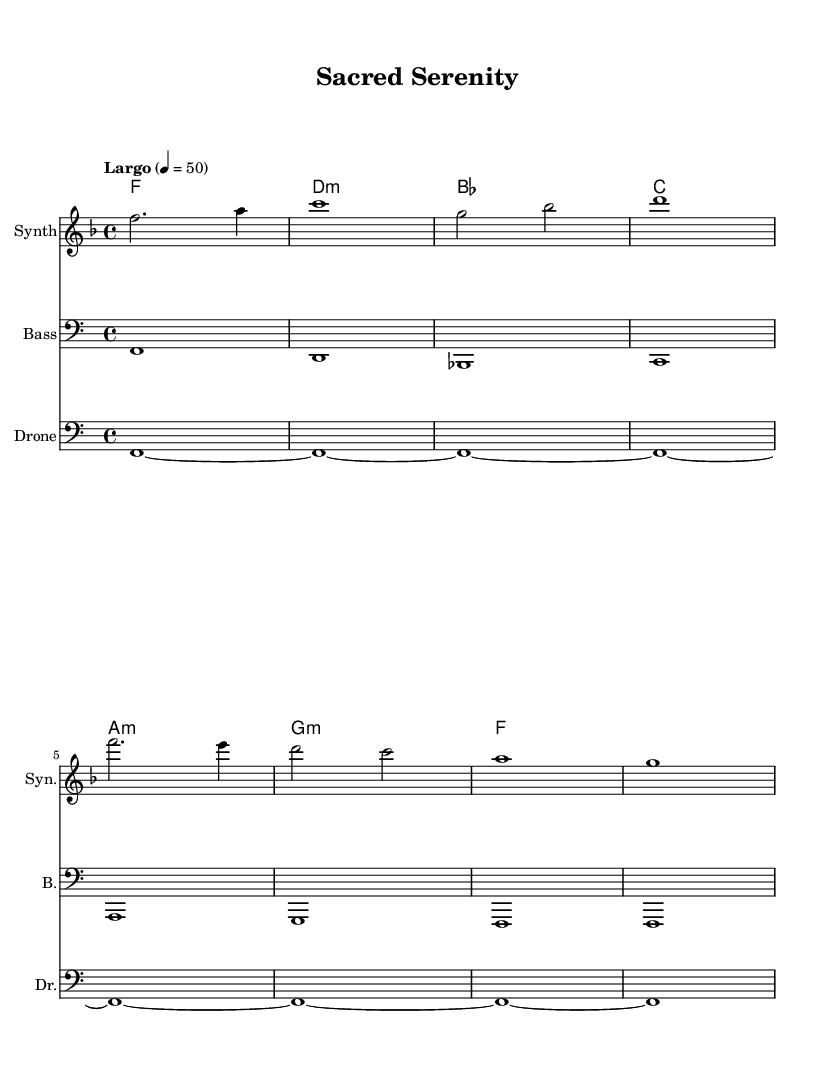What is the key signature of this music? The key signature is F major, which contains one flat (B flat). This can be identified by looking at the key signature indicated at the beginning of the staff.
Answer: F major What is the time signature of this music? The time signature is 4/4, which can be found at the beginning of the score, indicating that there are four beats in each measure, and the quarter note gets one beat.
Answer: 4/4 What is the tempo marking for this piece? The tempo marking is "Largo," which is indicated at the start of the score along with the metronome marking of 50 beats per minute.
Answer: Largo How many measures are there in the melody? There are eight measures in the melody section, as each line corresponds to a measure, and the melodic line contains eight distinct bars.
Answer: 8 What instrument is the melody written for? The melody is written for "Synth," as seen in the labeled staff above the melodic line. This indicates that the melody is intended to be played on a synthesizer.
Answer: Synth What type of harmony is used in this piece? The harmony is primarily made up of triads, specifically major and minor chords, as indicated by the chord names below each measure in the harmonies staff.
Answer: Triads What distinctive texture does the drone provide in this music? The drone provides a sustained tonal foundation, characterized by long notes held throughout the piece, which is typical in ambient electronic music.
Answer: Sustained tonal foundation 